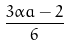Convert formula to latex. <formula><loc_0><loc_0><loc_500><loc_500>\frac { 3 \alpha a - 2 } { 6 }</formula> 